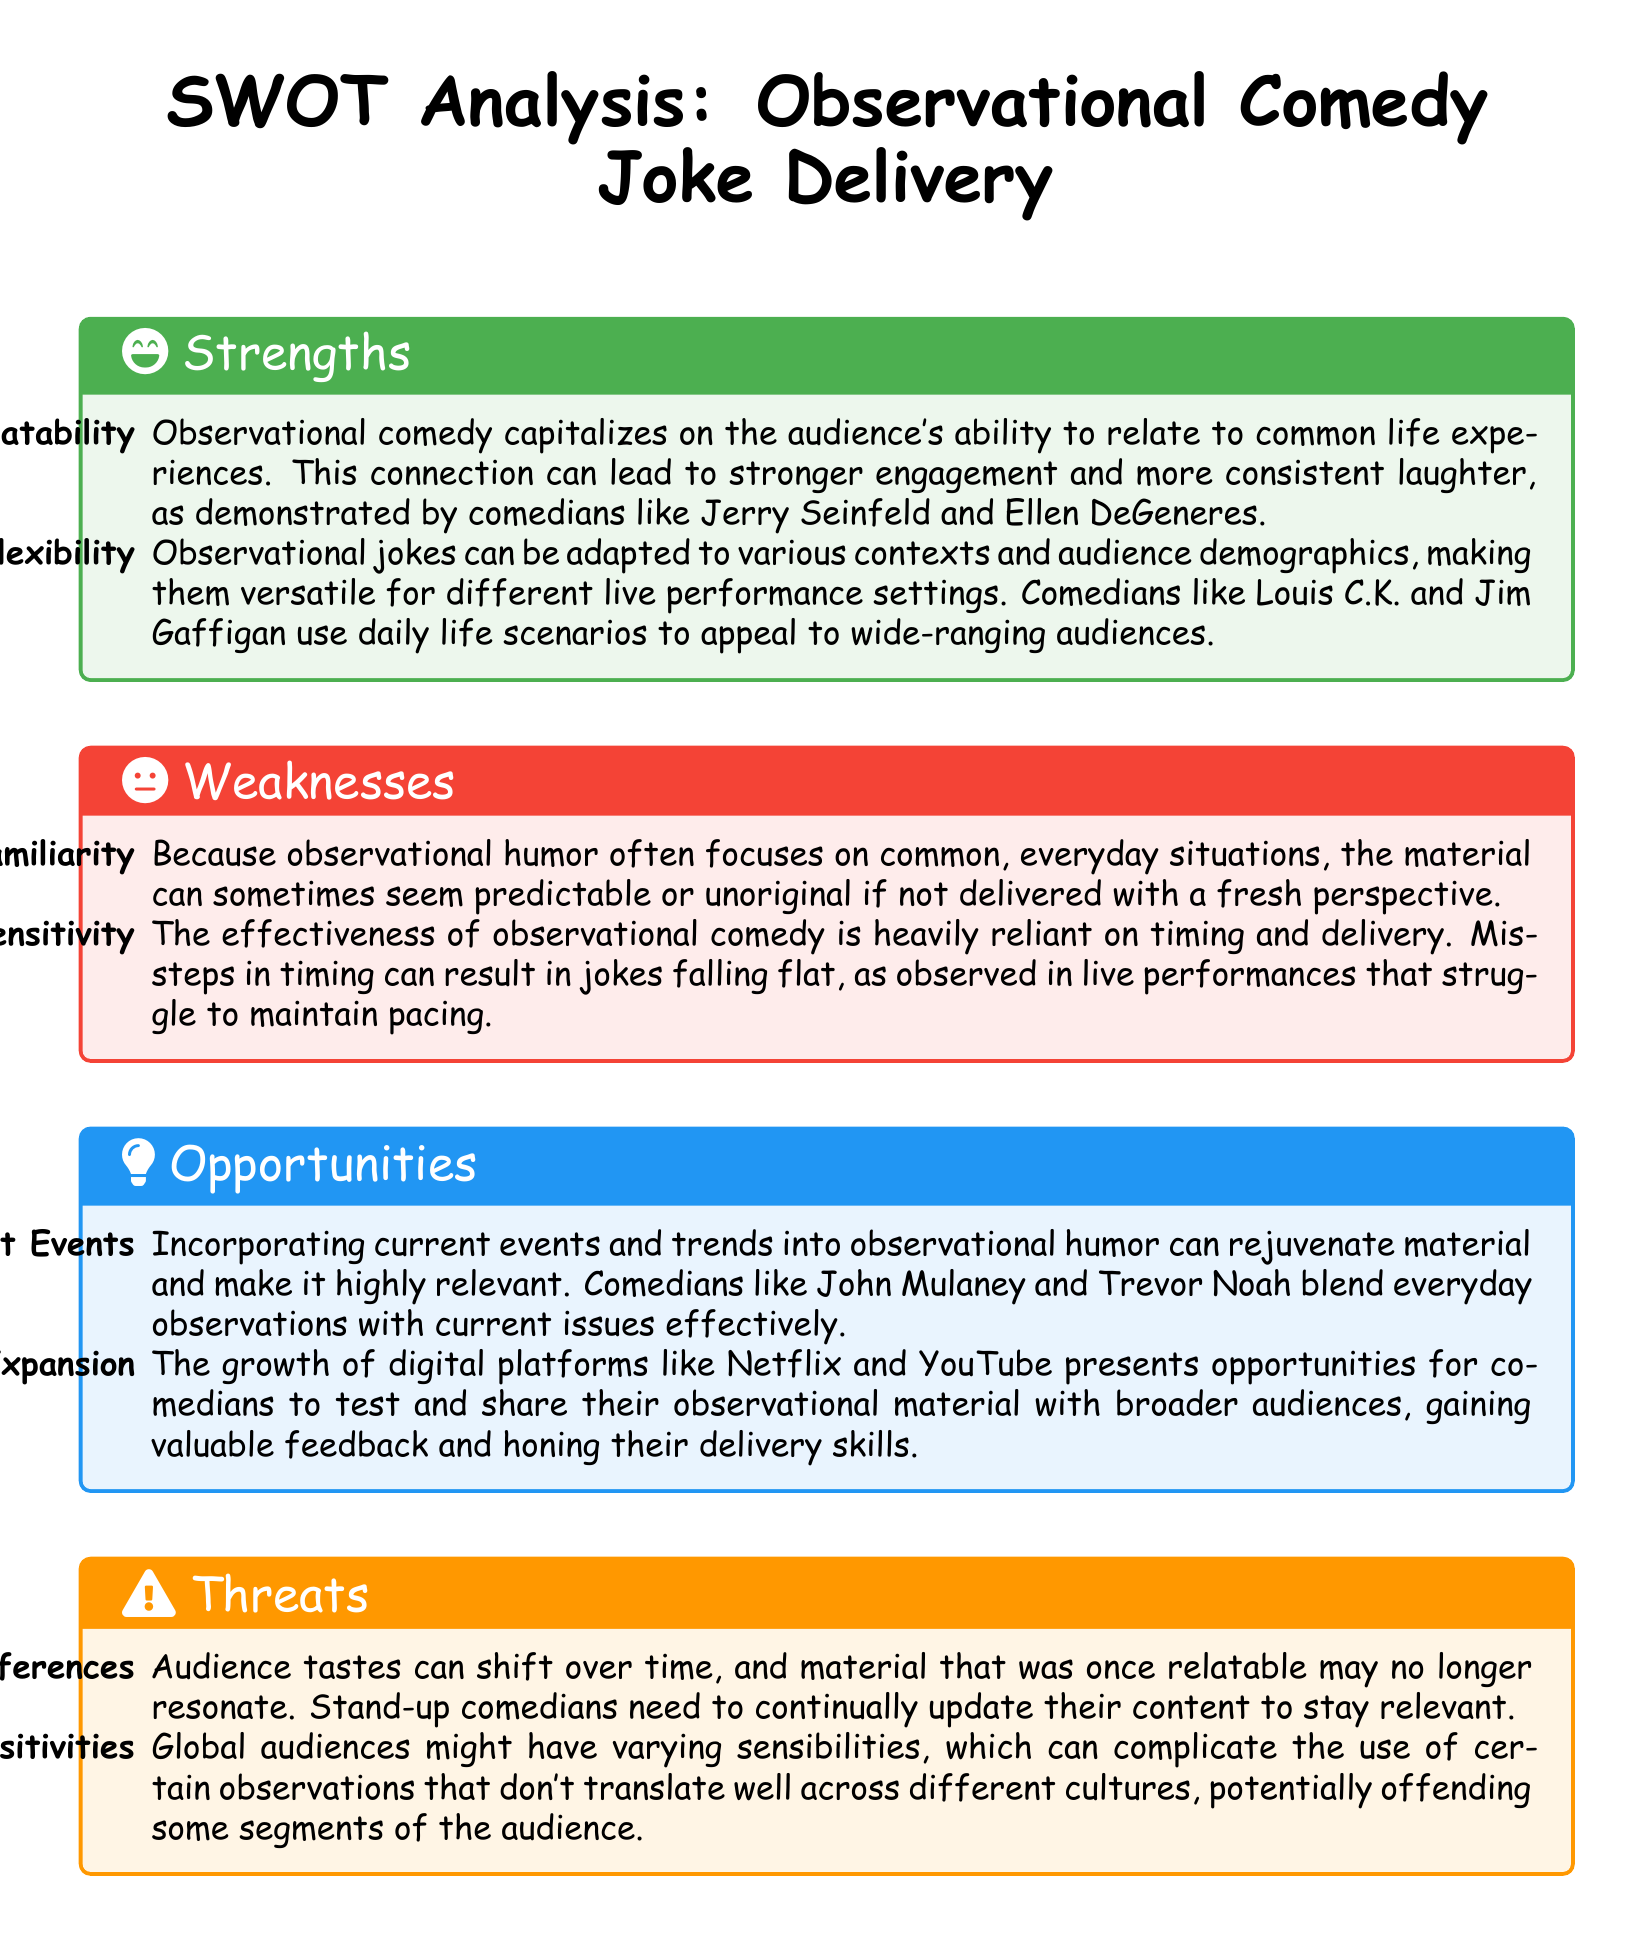What is the first strength listed? The first strength under "Strengths" is "Relatability," referring to the audience's ability to connect with common life experiences.
Answer: Relatability How many weaknesses are listed in the SWOT analysis? The document lists two weaknesses under "Weaknesses."
Answer: 2 Which comedian is mentioned as an example of someone who uses relatable material successfully? Jerry Seinfeld is mentioned as a comedian known for his observational style and relatability.
Answer: Jerry Seinfeld What is the second opportunity identified in the analysis? The second opportunity discusses the expansion of digital media platforms like Netflix and YouTube for sharing observational material.
Answer: Digital Media Expansion What color represents strengths in the SWOT analysis? The strengths section is color-coded with a light green shade indicated by the hex code #4CAF50.
Answer: Green Which section discusses the impact of audience preferences? The "Threats" section addresses the changing audience preferences that comedians must adapt to.
Answer: Threats How does observational comedy's effectiveness depend on timing? The effectiveness of observational comedy relies on timing and delivery, and missteps can cause jokes to fall flat.
Answer: Timing What is one potential threat regarding cultural sensitivities mentioned? The analysis highlights that cultural sensitivities can complicate the use of observations that may not resonate in different cultures.
Answer: Cultural Sensitivities Which comedian is cited for effectively blending observations with current events? John Mulaney is mentioned as a comedian who effectively incorporates current events into his observational humor.
Answer: John Mulaney 